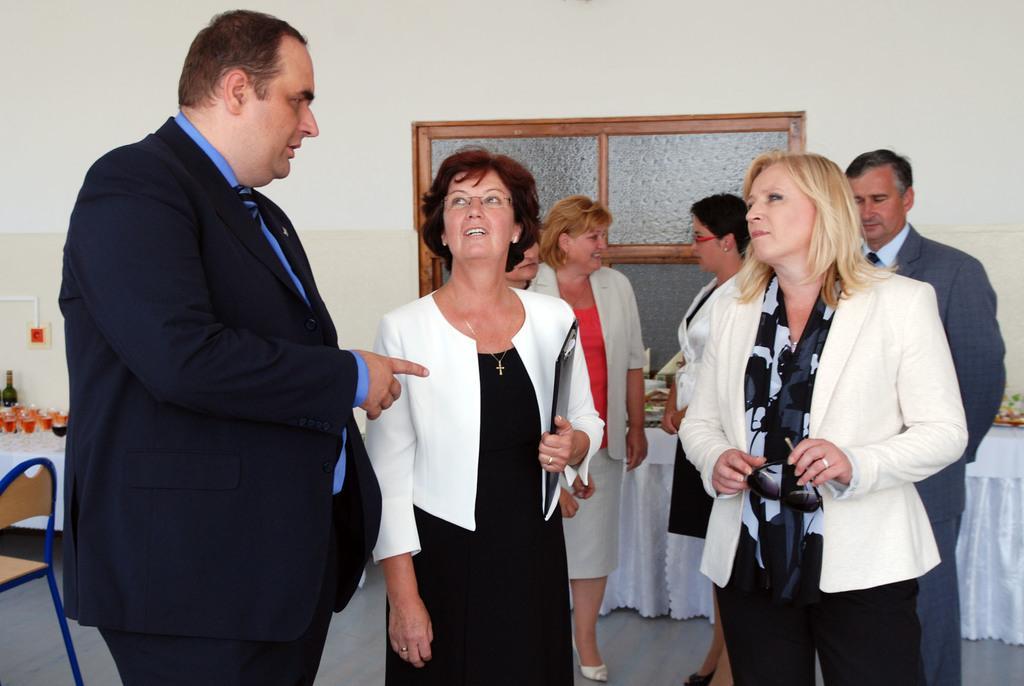Can you describe this image briefly? In this image I can see few persons standing. On the left side I can see a chair. I can see a bottle and few glasses. In the background I can see a window. 